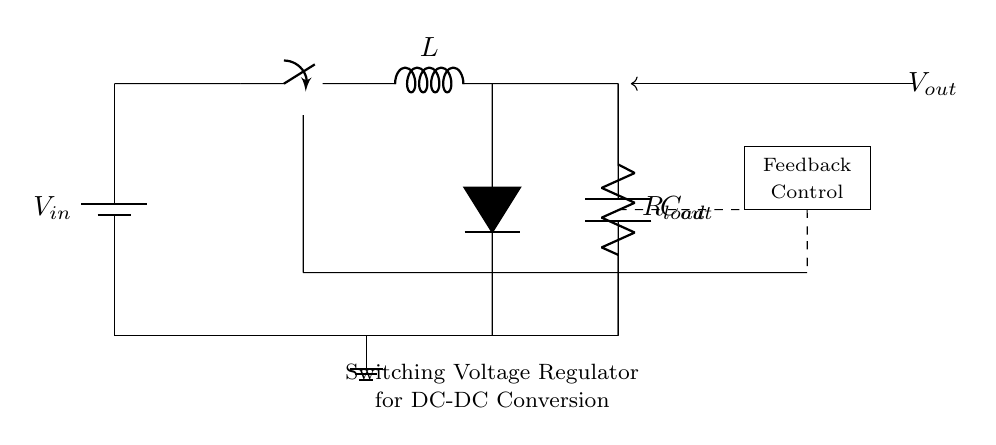What is the input voltage of the circuit? The input voltage is represented by the label V_in on the battery symbol in the circuit.
Answer: V_in What type of inductor is used in this regulator circuit? The inductor is labeled simply as L, indicating it is a generic inductor used for energy storage in the circuit.
Answer: L What function does the diode serve in this circuit? The diode, indicated as D*, allows current to flow in one direction only, preventing backflow when the switch is off, which protects the components.
Answer: Prevents backflow How many main components are directly involved in the energy conversion process in this circuit? The main components involved are the switch, inductor, capacitor, and diode, leading to a total of four components essential for energy conversion.
Answer: Four What role does the feedback control block play in this circuit? The feedback control block is responsible for monitoring the output voltage and adjusting the duty cycle of the switch to maintain a steady output voltage level.
Answer: Regulates output voltage What is the output capacitor labeled as in the circuit? The output capacitor is labeled C_out, indicating it is the capacitor used to smooth the output voltage provided to the load.
Answer: C_out Which component indicates the load in this circuit diagram? The load is indicated by the resistor labeled R_load, which represents the device or circuit consuming the output power from the regulator.
Answer: R_load 